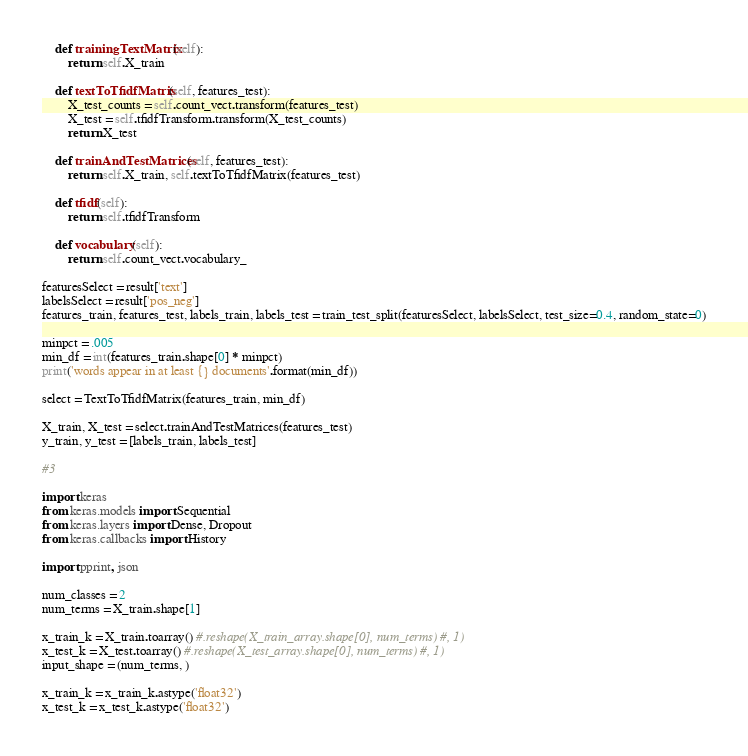<code> <loc_0><loc_0><loc_500><loc_500><_Python_>    def trainingTextMatrix(self):
        return self.X_train
    
    def textToTfidfMatrix(self, features_test):
        X_test_counts = self.count_vect.transform(features_test)
        X_test = self.tfidfTransform.transform(X_test_counts)
        return X_test
    
    def trainAndTestMatrices(self, features_test):
        return self.X_train, self.textToTfidfMatrix(features_test) 
    
    def tfidf(self):
        return self.tfidfTransform
    
    def vocabulary(self):
        return self.count_vect.vocabulary_

featuresSelect = result['text']
labelsSelect = result['pos_neg']
features_train, features_test, labels_train, labels_test = train_test_split(featuresSelect, labelsSelect, test_size=0.4, random_state=0)

minpct = .005
min_df = int(features_train.shape[0] * minpct)
print('words appear in at least {} documents'.format(min_df))

select = TextToTfidfMatrix(features_train, min_df)

X_train, X_test = select.trainAndTestMatrices(features_test)
y_train, y_test = [labels_train, labels_test]

#3 

import keras
from keras.models import Sequential
from keras.layers import Dense, Dropout 
from keras.callbacks import History 

import pprint, json

num_classes = 2
num_terms = X_train.shape[1]

x_train_k = X_train.toarray() #.reshape(X_train_array.shape[0], num_terms) #, 1)
x_test_k = X_test.toarray() #.reshape(X_test_array.shape[0], num_terms) #, 1)
input_shape = (num_terms, )

x_train_k = x_train_k.astype('float32')
x_test_k = x_test_k.astype('float32')
</code> 